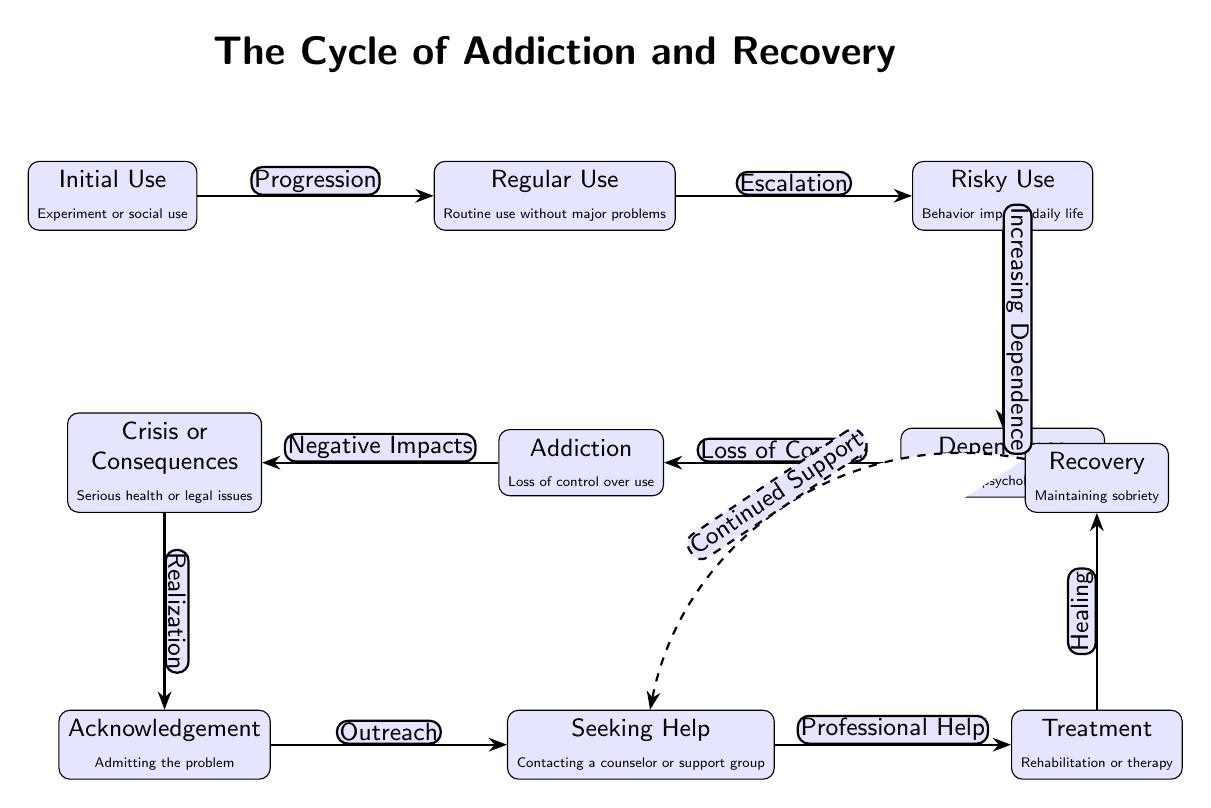What is the first stage in the cycle? The diagram shows the cycle starting with "Initial Use," which is indicated as the first node.
Answer: Initial Use How many stages are there in total? The diagram has ten distinct nodes that represent different stages in the cycle of addiction and recovery.
Answer: 10 What is the relationship between "Crisis or Consequences" and "Dependence"? The edge connecting these two nodes indicates "Negative Impacts," suggesting that facing crises or consequences can lead to dependence.
Answer: Negative Impacts What stage follows "Seeking Help"? According to the diagram, "Treatment" comes immediately after "Seeking Help," showing progression in the recovery process.
Answer: Treatment What does the dashed edge from "Recovery" to "Seeking Help" represent? The dashed edge is labeled "Continued Support," implying that ongoing support is necessary for maintaining recovery and prevents relapse.
Answer: Continued Support What is indicated by the node "Addiction"? This node signifies "Loss of control over use," marking a critical point in the cycle where individuals realize they have become addicted.
Answer: Loss of control over use Which stage shows the need for Acknowledgment? The "Acknowledgement" node comes after "Crisis or Consequences," indicating that recognizing the problem is essential for moving forward in recovery.
Answer: Acknowledgement What is the key transition from "Dependence" to "Addiction"? The transition is described as "Loss of Control," highlighting how dependence escalates into addiction due to diminished ability to manage usage.
Answer: Loss of Control Which stage reflects the decision to contact a counselor? The "Seeking Help" stage clearly captures the action where individuals choose to reach out for assistance in managing their addiction issues.
Answer: Seeking Help 